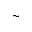Convert formula to latex. <formula><loc_0><loc_0><loc_500><loc_500>\sim</formula> 